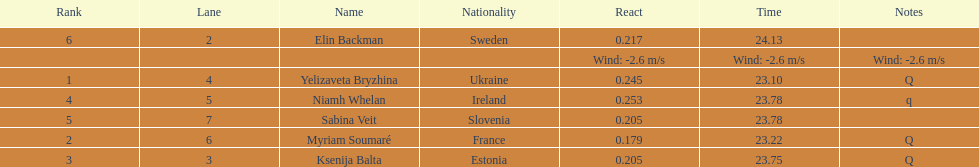Are any of the lanes in consecutive order? No. 